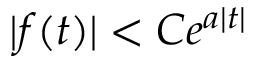Convert formula to latex. <formula><loc_0><loc_0><loc_500><loc_500>| f ( t ) | < C e ^ { a | t | }</formula> 